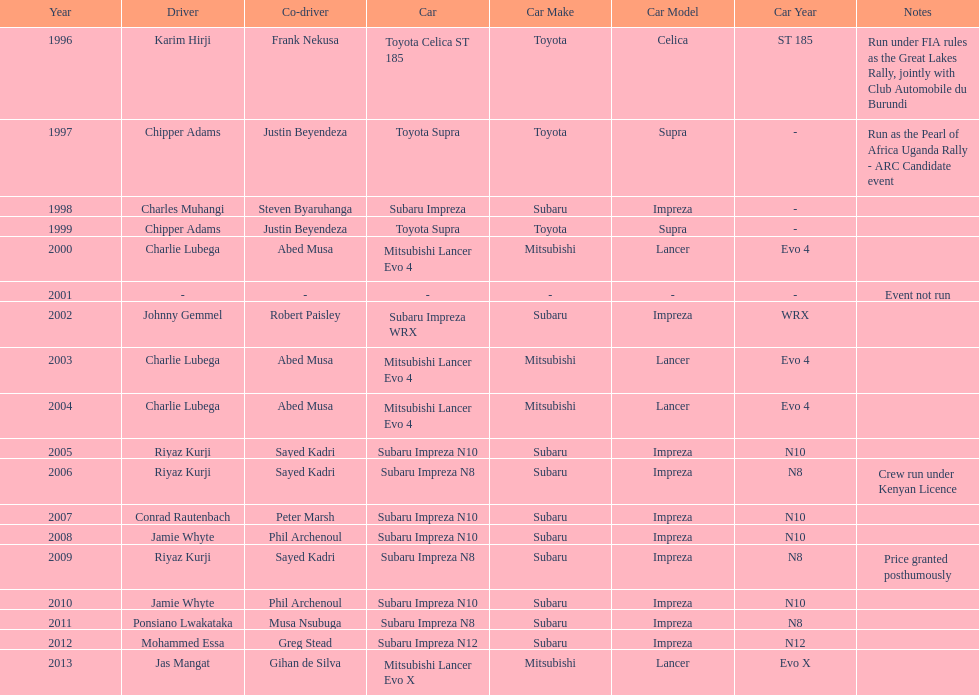Who is the only driver to have consecutive wins? Charlie Lubega. 